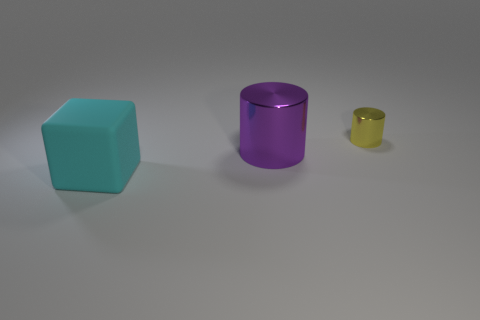Add 1 large cyan blocks. How many objects exist? 4 Subtract all gray cubes. How many purple cylinders are left? 1 Subtract all small blue metal blocks. Subtract all tiny metallic things. How many objects are left? 2 Add 3 tiny cylinders. How many tiny cylinders are left? 4 Add 3 large cyan rubber objects. How many large cyan rubber objects exist? 4 Subtract 1 purple cylinders. How many objects are left? 2 Subtract all blocks. How many objects are left? 2 Subtract 1 cubes. How many cubes are left? 0 Subtract all green cylinders. Subtract all gray cubes. How many cylinders are left? 2 